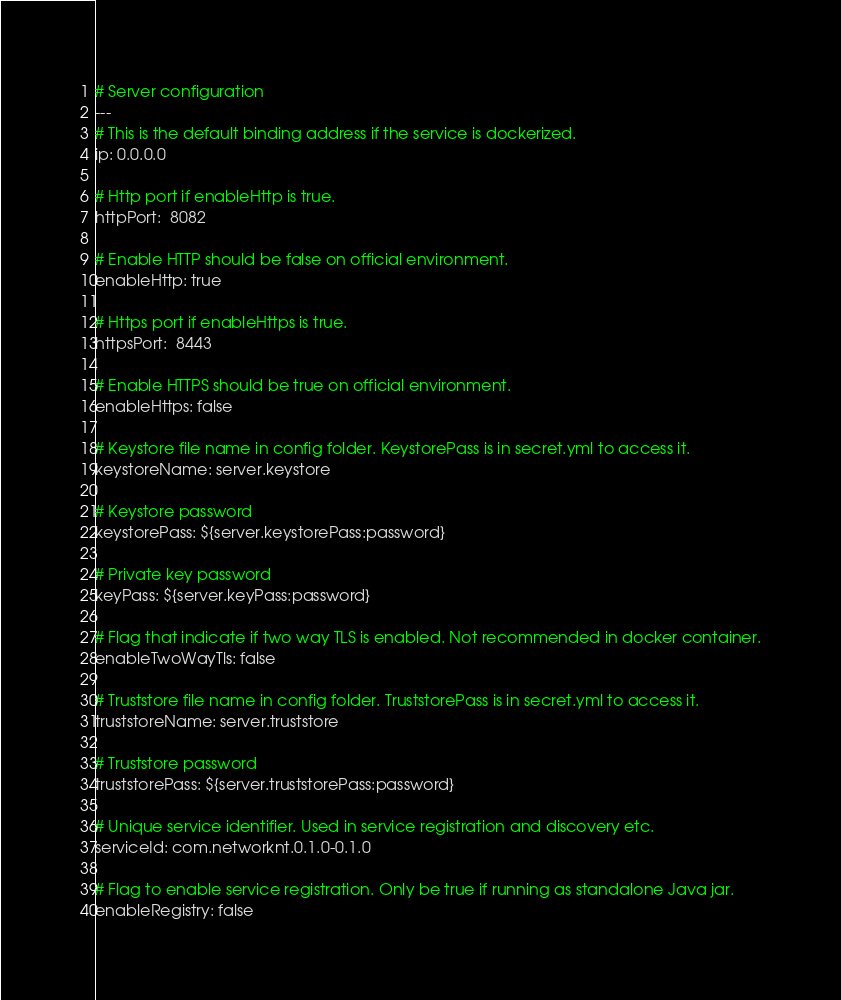Convert code to text. <code><loc_0><loc_0><loc_500><loc_500><_YAML_>
# Server configuration
---
# This is the default binding address if the service is dockerized.
ip: 0.0.0.0

# Http port if enableHttp is true.
httpPort:  8082

# Enable HTTP should be false on official environment.
enableHttp: true

# Https port if enableHttps is true.
httpsPort:  8443

# Enable HTTPS should be true on official environment.
enableHttps: false

# Keystore file name in config folder. KeystorePass is in secret.yml to access it.
keystoreName: server.keystore

# Keystore password
keystorePass: ${server.keystorePass:password}

# Private key password
keyPass: ${server.keyPass:password}

# Flag that indicate if two way TLS is enabled. Not recommended in docker container.
enableTwoWayTls: false

# Truststore file name in config folder. TruststorePass is in secret.yml to access it.
truststoreName: server.truststore

# Truststore password
truststorePass: ${server.truststorePass:password}

# Unique service identifier. Used in service registration and discovery etc.
serviceId: com.networknt.0.1.0-0.1.0

# Flag to enable service registration. Only be true if running as standalone Java jar.
enableRegistry: false
</code> 